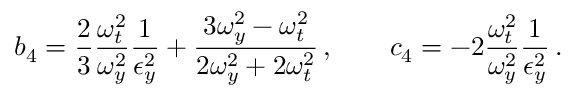<formula> <loc_0><loc_0><loc_500><loc_500>b _ { 4 } = \frac { 2 } { 3 } \frac { \omega _ { t } ^ { 2 } } { \omega _ { y } ^ { 2 } } \frac { 1 } { \epsilon _ { y } ^ { 2 } } + \frac { 3 \omega _ { y } ^ { 2 } - \omega _ { t } ^ { 2 } } { 2 \omega _ { y } ^ { 2 } + 2 \omega _ { t } ^ { 2 } } \, , \quad c _ { 4 } = - 2 \frac { \omega _ { t } ^ { 2 } } { \omega _ { y } ^ { 2 } } \frac { 1 } { \epsilon _ { y } ^ { 2 } } \, .</formula> 